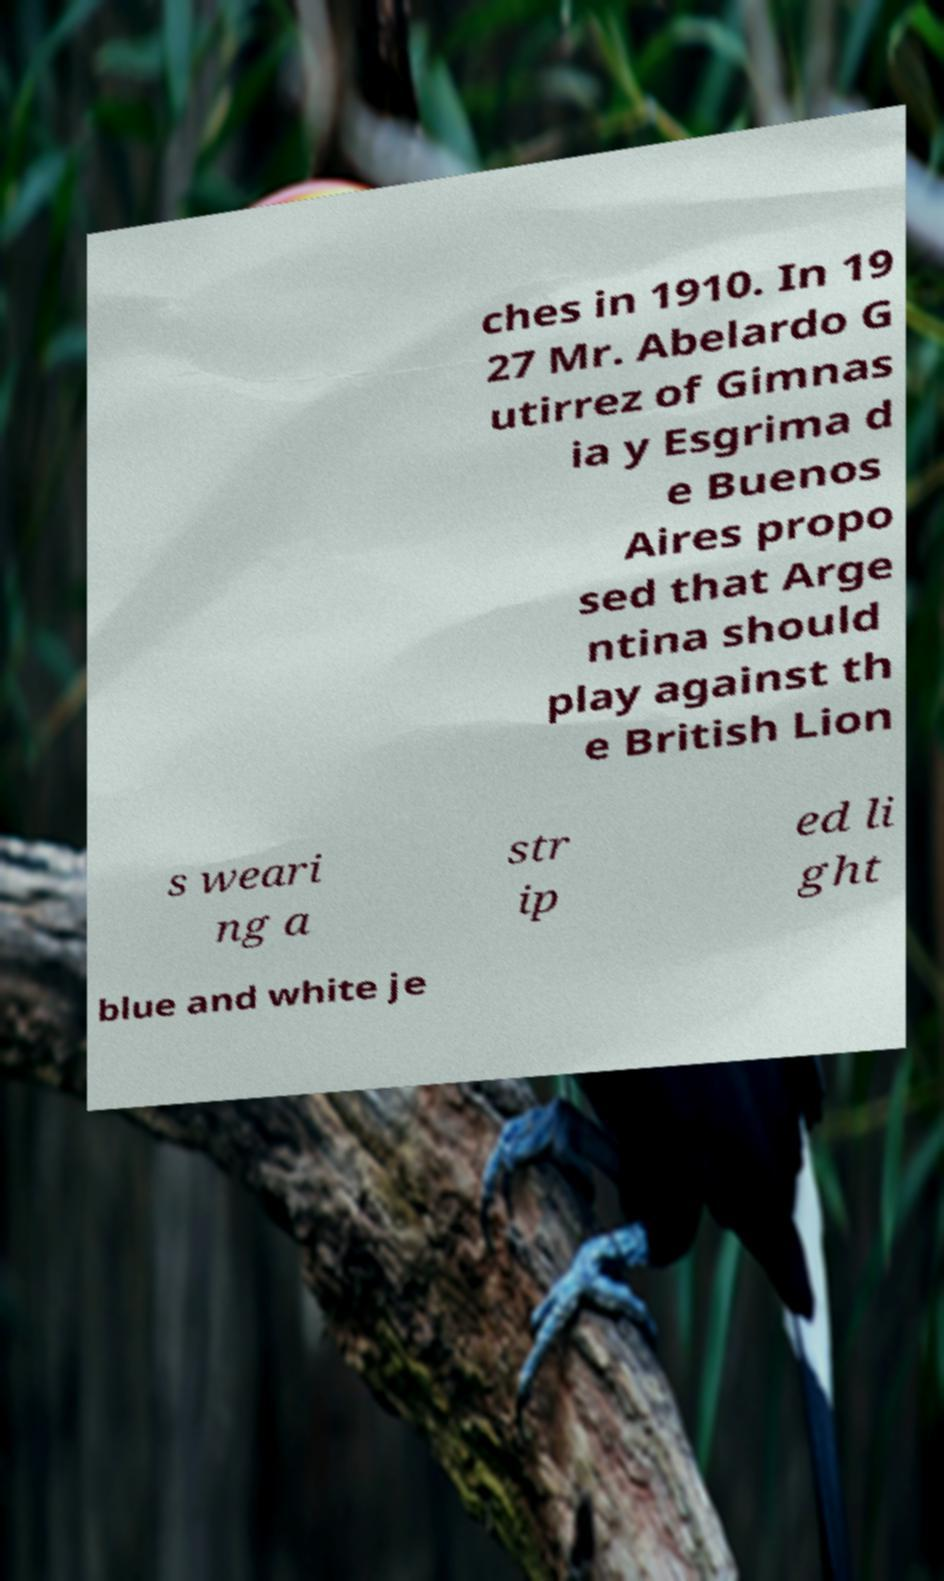Can you read and provide the text displayed in the image?This photo seems to have some interesting text. Can you extract and type it out for me? ches in 1910. In 19 27 Mr. Abelardo G utirrez of Gimnas ia y Esgrima d e Buenos Aires propo sed that Arge ntina should play against th e British Lion s weari ng a str ip ed li ght blue and white je 